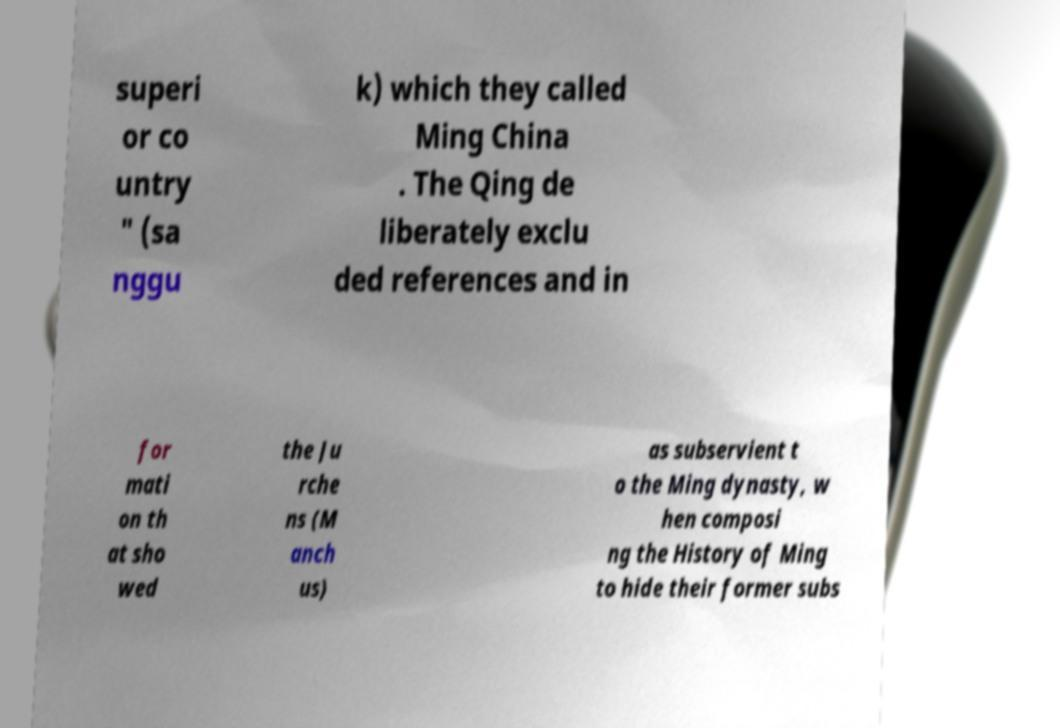Please identify and transcribe the text found in this image. superi or co untry " (sa nggu k) which they called Ming China . The Qing de liberately exclu ded references and in for mati on th at sho wed the Ju rche ns (M anch us) as subservient t o the Ming dynasty, w hen composi ng the History of Ming to hide their former subs 